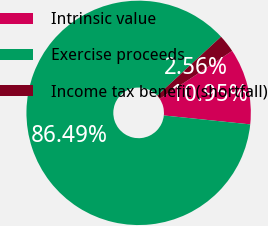<chart> <loc_0><loc_0><loc_500><loc_500><pie_chart><fcel>Intrinsic value<fcel>Exercise proceeds<fcel>Income tax benefit (shortfall)<nl><fcel>10.95%<fcel>86.49%<fcel>2.56%<nl></chart> 